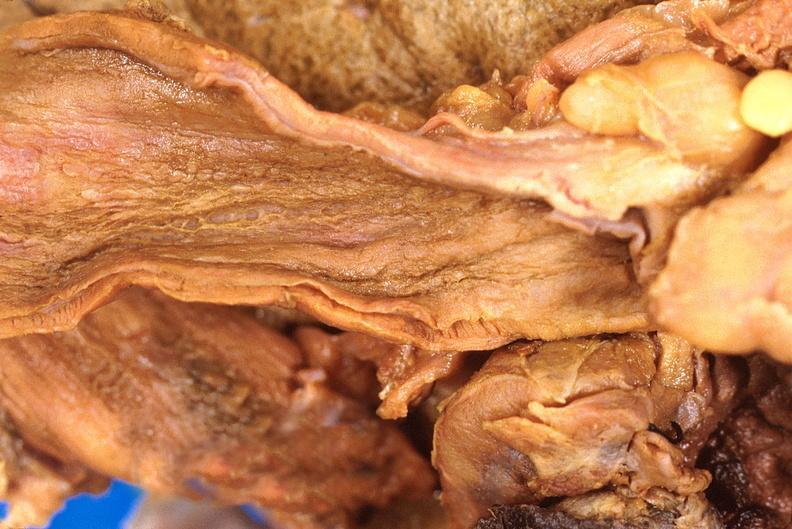what ingested as suicide attempt?
Answer the question using a single word or phrase. Stomach, necrotizing esophagitis and gastritis, sulfuric acid 